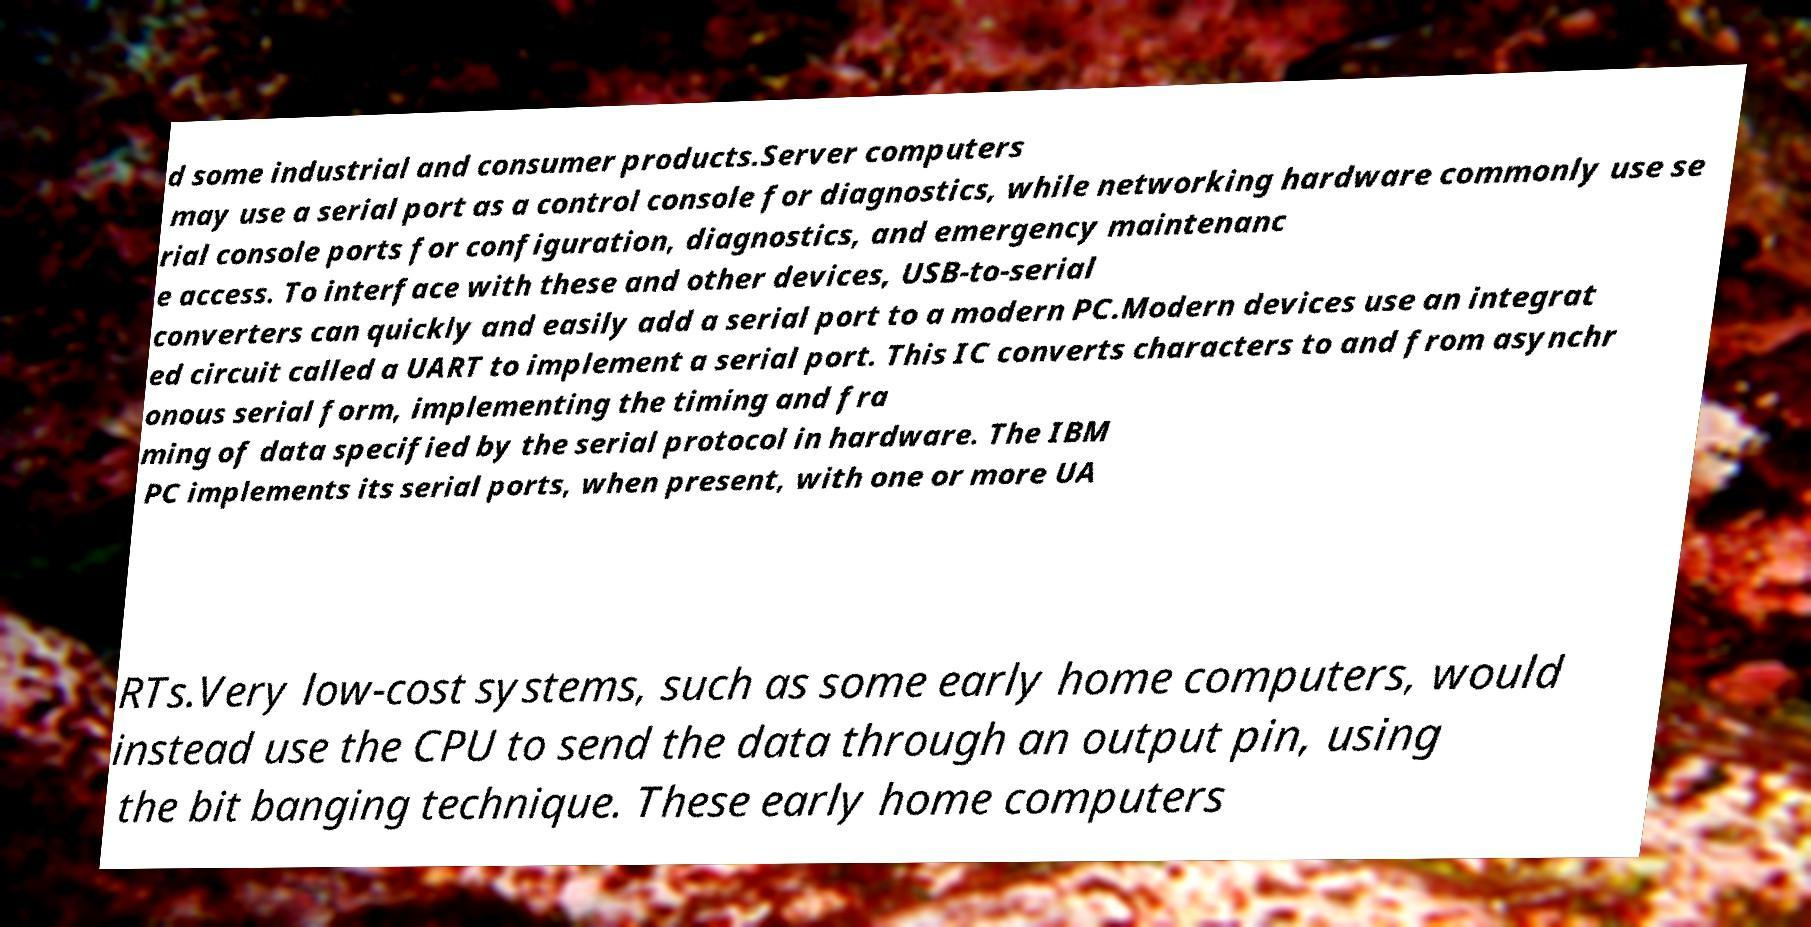There's text embedded in this image that I need extracted. Can you transcribe it verbatim? d some industrial and consumer products.Server computers may use a serial port as a control console for diagnostics, while networking hardware commonly use se rial console ports for configuration, diagnostics, and emergency maintenanc e access. To interface with these and other devices, USB-to-serial converters can quickly and easily add a serial port to a modern PC.Modern devices use an integrat ed circuit called a UART to implement a serial port. This IC converts characters to and from asynchr onous serial form, implementing the timing and fra ming of data specified by the serial protocol in hardware. The IBM PC implements its serial ports, when present, with one or more UA RTs.Very low-cost systems, such as some early home computers, would instead use the CPU to send the data through an output pin, using the bit banging technique. These early home computers 